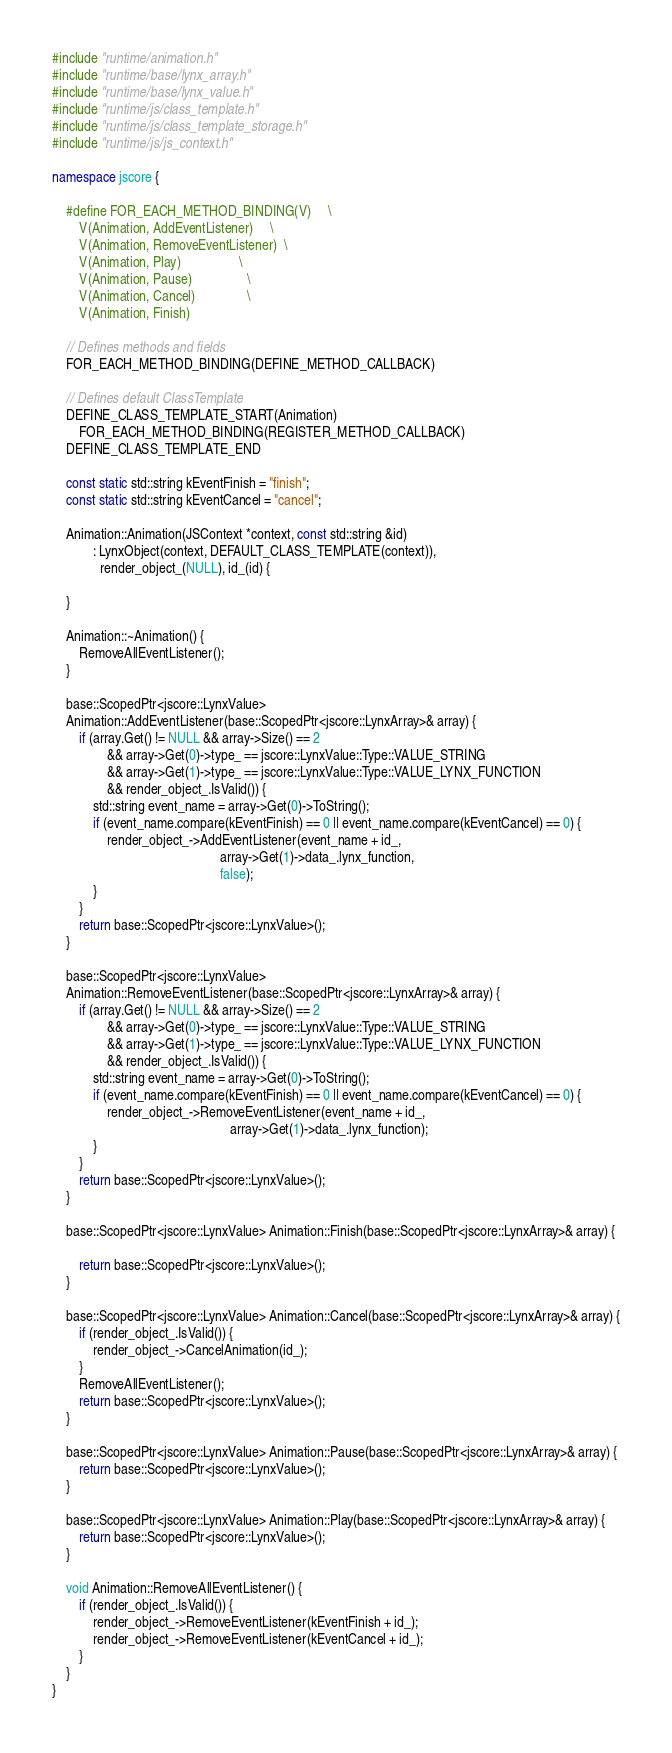Convert code to text. <code><loc_0><loc_0><loc_500><loc_500><_C++_>
#include "runtime/animation.h"
#include "runtime/base/lynx_array.h"
#include "runtime/base/lynx_value.h"
#include "runtime/js/class_template.h"
#include "runtime/js/class_template_storage.h"
#include "runtime/js/js_context.h"

namespace jscore {

    #define FOR_EACH_METHOD_BINDING(V)     \
        V(Animation, AddEventListener)     \
        V(Animation, RemoveEventListener)  \
        V(Animation, Play)                 \
        V(Animation, Pause)                \
        V(Animation, Cancel)               \
        V(Animation, Finish)

    // Defines methods and fields
    FOR_EACH_METHOD_BINDING(DEFINE_METHOD_CALLBACK)

    // Defines default ClassTemplate
    DEFINE_CLASS_TEMPLATE_START(Animation)
        FOR_EACH_METHOD_BINDING(REGISTER_METHOD_CALLBACK)
    DEFINE_CLASS_TEMPLATE_END

    const static std::string kEventFinish = "finish";
    const static std::string kEventCancel = "cancel";

    Animation::Animation(JSContext *context, const std::string &id)
            : LynxObject(context, DEFAULT_CLASS_TEMPLATE(context)),
              render_object_(NULL), id_(id) {

    }

    Animation::~Animation() {
        RemoveAllEventListener();
    }

    base::ScopedPtr<jscore::LynxValue>
    Animation::AddEventListener(base::ScopedPtr<jscore::LynxArray>& array) {
        if (array.Get() != NULL && array->Size() == 2
                && array->Get(0)->type_ == jscore::LynxValue::Type::VALUE_STRING
                && array->Get(1)->type_ == jscore::LynxValue::Type::VALUE_LYNX_FUNCTION
                && render_object_.IsValid()) {
            std::string event_name = array->Get(0)->ToString();
            if (event_name.compare(kEventFinish) == 0 || event_name.compare(kEventCancel) == 0) {
                render_object_->AddEventListener(event_name + id_,
                                                 array->Get(1)->data_.lynx_function,
                                                 false);
            }
        }
        return base::ScopedPtr<jscore::LynxValue>();
    }
    
    base::ScopedPtr<jscore::LynxValue>
    Animation::RemoveEventListener(base::ScopedPtr<jscore::LynxArray>& array) {
        if (array.Get() != NULL && array->Size() == 2
                && array->Get(0)->type_ == jscore::LynxValue::Type::VALUE_STRING
                && array->Get(1)->type_ == jscore::LynxValue::Type::VALUE_LYNX_FUNCTION
                && render_object_.IsValid()) {
            std::string event_name = array->Get(0)->ToString();
            if (event_name.compare(kEventFinish) == 0 || event_name.compare(kEventCancel) == 0) {
                render_object_->RemoveEventListener(event_name + id_,
                                                    array->Get(1)->data_.lynx_function);
            }
        }
        return base::ScopedPtr<jscore::LynxValue>();
    }

    base::ScopedPtr<jscore::LynxValue> Animation::Finish(base::ScopedPtr<jscore::LynxArray>& array) {

        return base::ScopedPtr<jscore::LynxValue>();
    }

    base::ScopedPtr<jscore::LynxValue> Animation::Cancel(base::ScopedPtr<jscore::LynxArray>& array) {
        if (render_object_.IsValid()) {
            render_object_->CancelAnimation(id_);
        }
        RemoveAllEventListener();
        return base::ScopedPtr<jscore::LynxValue>();
    }

    base::ScopedPtr<jscore::LynxValue> Animation::Pause(base::ScopedPtr<jscore::LynxArray>& array) {
        return base::ScopedPtr<jscore::LynxValue>();
    }

    base::ScopedPtr<jscore::LynxValue> Animation::Play(base::ScopedPtr<jscore::LynxArray>& array) {
        return base::ScopedPtr<jscore::LynxValue>();
    }

    void Animation::RemoveAllEventListener() {
        if (render_object_.IsValid()) {
            render_object_->RemoveEventListener(kEventFinish + id_);
            render_object_->RemoveEventListener(kEventCancel + id_);
        }
    }
}
</code> 